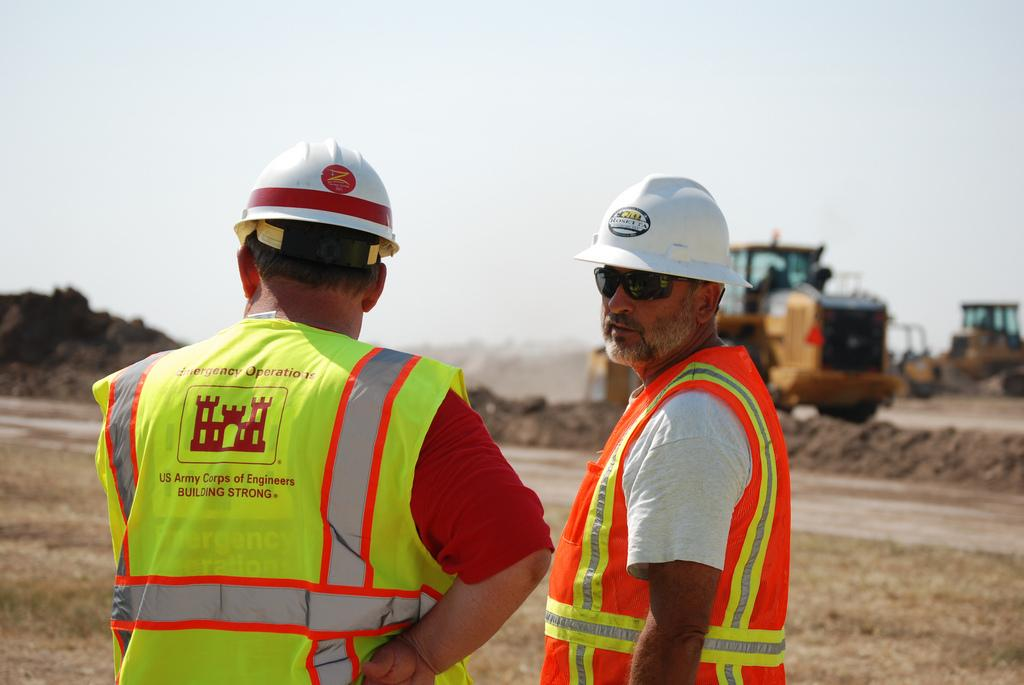How many people are in the image? There are two people in the image. What are the people doing in the image? The people are standing. What are the people wearing on their heads? The people are wearing white helmets. What type of clothing are the people wearing? The people are wearing uniforms. What can be seen in the background of the image? There are vehicles in the background of the image. What is visible at the top of the image? The sky is visible at the top of the image. What type of beast can be seen making noise in the image? There is no beast present in the image, and therefore no such activity can be observed. What is the purpose of the bells in the image? There are no bells present in the image. 